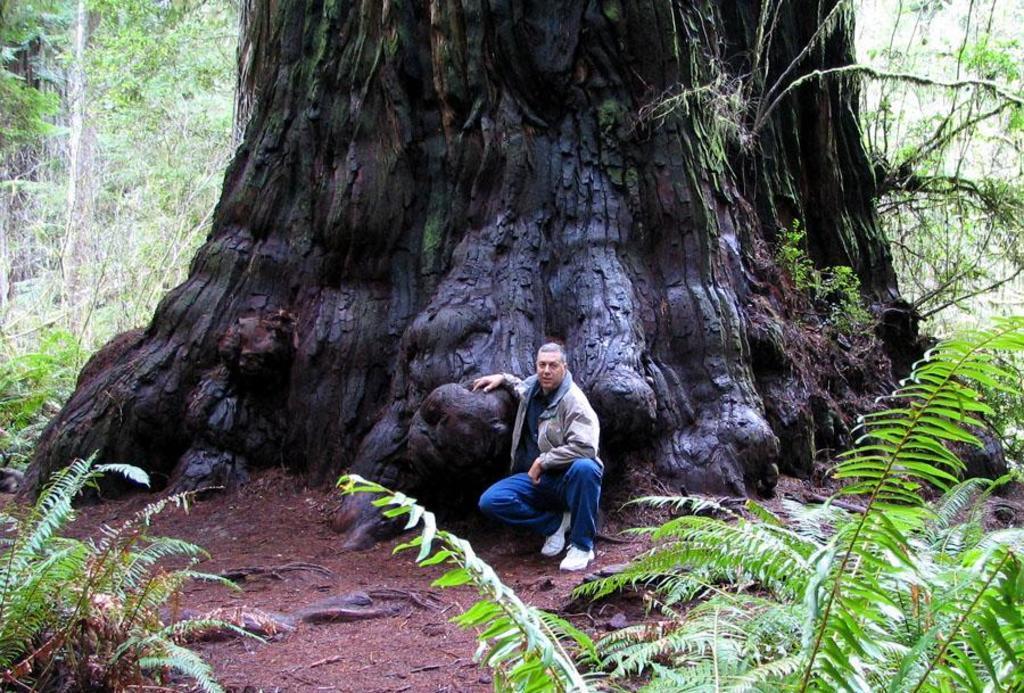Can you describe this image briefly? In foreground there are plants, soil and roots. In the center of the picture there is a person standing near a huge trunk of a tree. In the background there are plants and trees. 